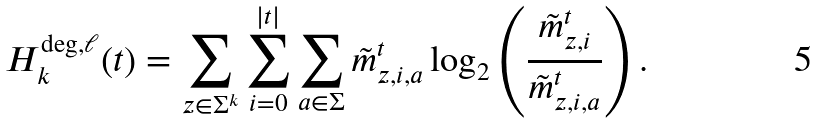<formula> <loc_0><loc_0><loc_500><loc_500>H _ { k } ^ { \deg , \ell } ( t ) = \sum _ { z \in \Sigma ^ { k } } \sum _ { i = 0 } ^ { | t | } \sum _ { a \in \Sigma } \tilde { m } _ { z , i , a } ^ { t } \log _ { 2 } \left ( \frac { \tilde { m } _ { z , i } ^ { t } } { \tilde { m } _ { z , i , a } ^ { t } } \right ) .</formula> 